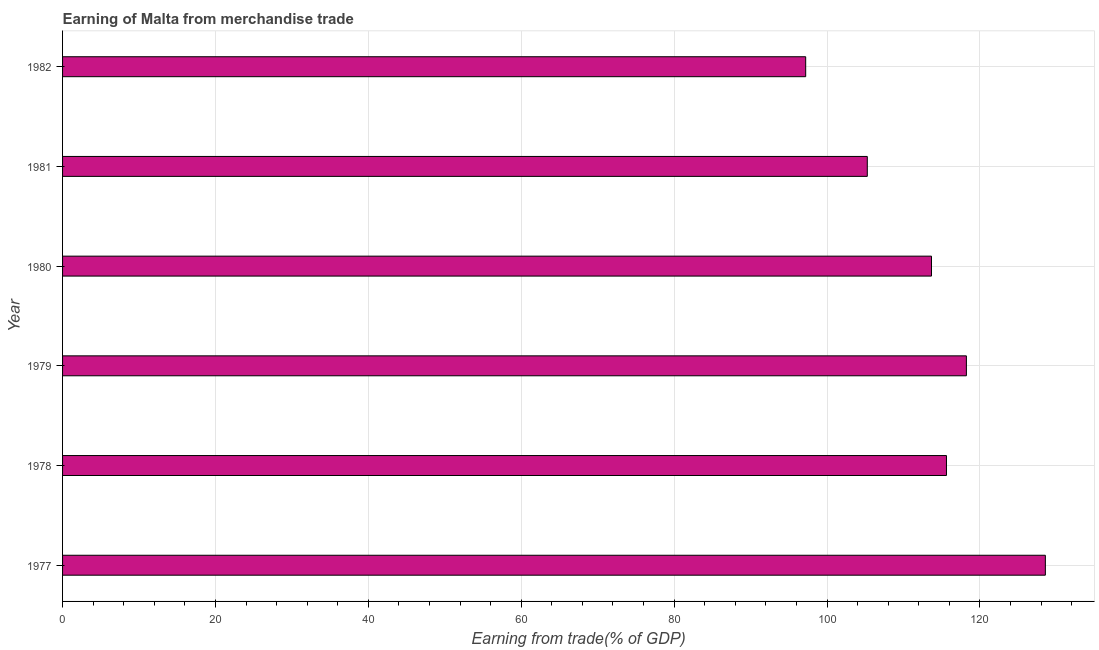Does the graph contain grids?
Your response must be concise. Yes. What is the title of the graph?
Your answer should be very brief. Earning of Malta from merchandise trade. What is the label or title of the X-axis?
Provide a succinct answer. Earning from trade(% of GDP). What is the label or title of the Y-axis?
Provide a succinct answer. Year. What is the earning from merchandise trade in 1978?
Provide a succinct answer. 115.62. Across all years, what is the maximum earning from merchandise trade?
Provide a succinct answer. 128.56. Across all years, what is the minimum earning from merchandise trade?
Offer a very short reply. 97.21. In which year was the earning from merchandise trade minimum?
Your answer should be compact. 1982. What is the sum of the earning from merchandise trade?
Ensure brevity in your answer.  678.54. What is the difference between the earning from merchandise trade in 1981 and 1982?
Ensure brevity in your answer.  8.06. What is the average earning from merchandise trade per year?
Ensure brevity in your answer.  113.09. What is the median earning from merchandise trade?
Keep it short and to the point. 114.64. In how many years, is the earning from merchandise trade greater than 80 %?
Keep it short and to the point. 6. Do a majority of the years between 1977 and 1981 (inclusive) have earning from merchandise trade greater than 112 %?
Your answer should be very brief. Yes. What is the ratio of the earning from merchandise trade in 1978 to that in 1979?
Give a very brief answer. 0.98. Is the earning from merchandise trade in 1978 less than that in 1980?
Make the answer very short. No. Is the difference between the earning from merchandise trade in 1980 and 1982 greater than the difference between any two years?
Offer a terse response. No. What is the difference between the highest and the second highest earning from merchandise trade?
Your answer should be compact. 10.33. What is the difference between the highest and the lowest earning from merchandise trade?
Provide a succinct answer. 31.35. Are all the bars in the graph horizontal?
Your response must be concise. Yes. What is the Earning from trade(% of GDP) in 1977?
Keep it short and to the point. 128.56. What is the Earning from trade(% of GDP) of 1978?
Offer a very short reply. 115.62. What is the Earning from trade(% of GDP) of 1979?
Make the answer very short. 118.23. What is the Earning from trade(% of GDP) in 1980?
Provide a short and direct response. 113.66. What is the Earning from trade(% of GDP) in 1981?
Keep it short and to the point. 105.27. What is the Earning from trade(% of GDP) of 1982?
Keep it short and to the point. 97.21. What is the difference between the Earning from trade(% of GDP) in 1977 and 1978?
Ensure brevity in your answer.  12.93. What is the difference between the Earning from trade(% of GDP) in 1977 and 1979?
Your answer should be very brief. 10.33. What is the difference between the Earning from trade(% of GDP) in 1977 and 1980?
Make the answer very short. 14.9. What is the difference between the Earning from trade(% of GDP) in 1977 and 1981?
Your answer should be very brief. 23.29. What is the difference between the Earning from trade(% of GDP) in 1977 and 1982?
Keep it short and to the point. 31.35. What is the difference between the Earning from trade(% of GDP) in 1978 and 1979?
Make the answer very short. -2.61. What is the difference between the Earning from trade(% of GDP) in 1978 and 1980?
Offer a very short reply. 1.96. What is the difference between the Earning from trade(% of GDP) in 1978 and 1981?
Keep it short and to the point. 10.36. What is the difference between the Earning from trade(% of GDP) in 1978 and 1982?
Your answer should be very brief. 18.42. What is the difference between the Earning from trade(% of GDP) in 1979 and 1980?
Keep it short and to the point. 4.57. What is the difference between the Earning from trade(% of GDP) in 1979 and 1981?
Your answer should be compact. 12.96. What is the difference between the Earning from trade(% of GDP) in 1979 and 1982?
Offer a terse response. 21.02. What is the difference between the Earning from trade(% of GDP) in 1980 and 1981?
Give a very brief answer. 8.4. What is the difference between the Earning from trade(% of GDP) in 1980 and 1982?
Your answer should be compact. 16.45. What is the difference between the Earning from trade(% of GDP) in 1981 and 1982?
Offer a terse response. 8.06. What is the ratio of the Earning from trade(% of GDP) in 1977 to that in 1978?
Provide a short and direct response. 1.11. What is the ratio of the Earning from trade(% of GDP) in 1977 to that in 1979?
Provide a succinct answer. 1.09. What is the ratio of the Earning from trade(% of GDP) in 1977 to that in 1980?
Provide a short and direct response. 1.13. What is the ratio of the Earning from trade(% of GDP) in 1977 to that in 1981?
Provide a short and direct response. 1.22. What is the ratio of the Earning from trade(% of GDP) in 1977 to that in 1982?
Give a very brief answer. 1.32. What is the ratio of the Earning from trade(% of GDP) in 1978 to that in 1981?
Offer a very short reply. 1.1. What is the ratio of the Earning from trade(% of GDP) in 1978 to that in 1982?
Offer a very short reply. 1.19. What is the ratio of the Earning from trade(% of GDP) in 1979 to that in 1980?
Offer a very short reply. 1.04. What is the ratio of the Earning from trade(% of GDP) in 1979 to that in 1981?
Provide a short and direct response. 1.12. What is the ratio of the Earning from trade(% of GDP) in 1979 to that in 1982?
Ensure brevity in your answer.  1.22. What is the ratio of the Earning from trade(% of GDP) in 1980 to that in 1981?
Keep it short and to the point. 1.08. What is the ratio of the Earning from trade(% of GDP) in 1980 to that in 1982?
Provide a succinct answer. 1.17. What is the ratio of the Earning from trade(% of GDP) in 1981 to that in 1982?
Offer a very short reply. 1.08. 